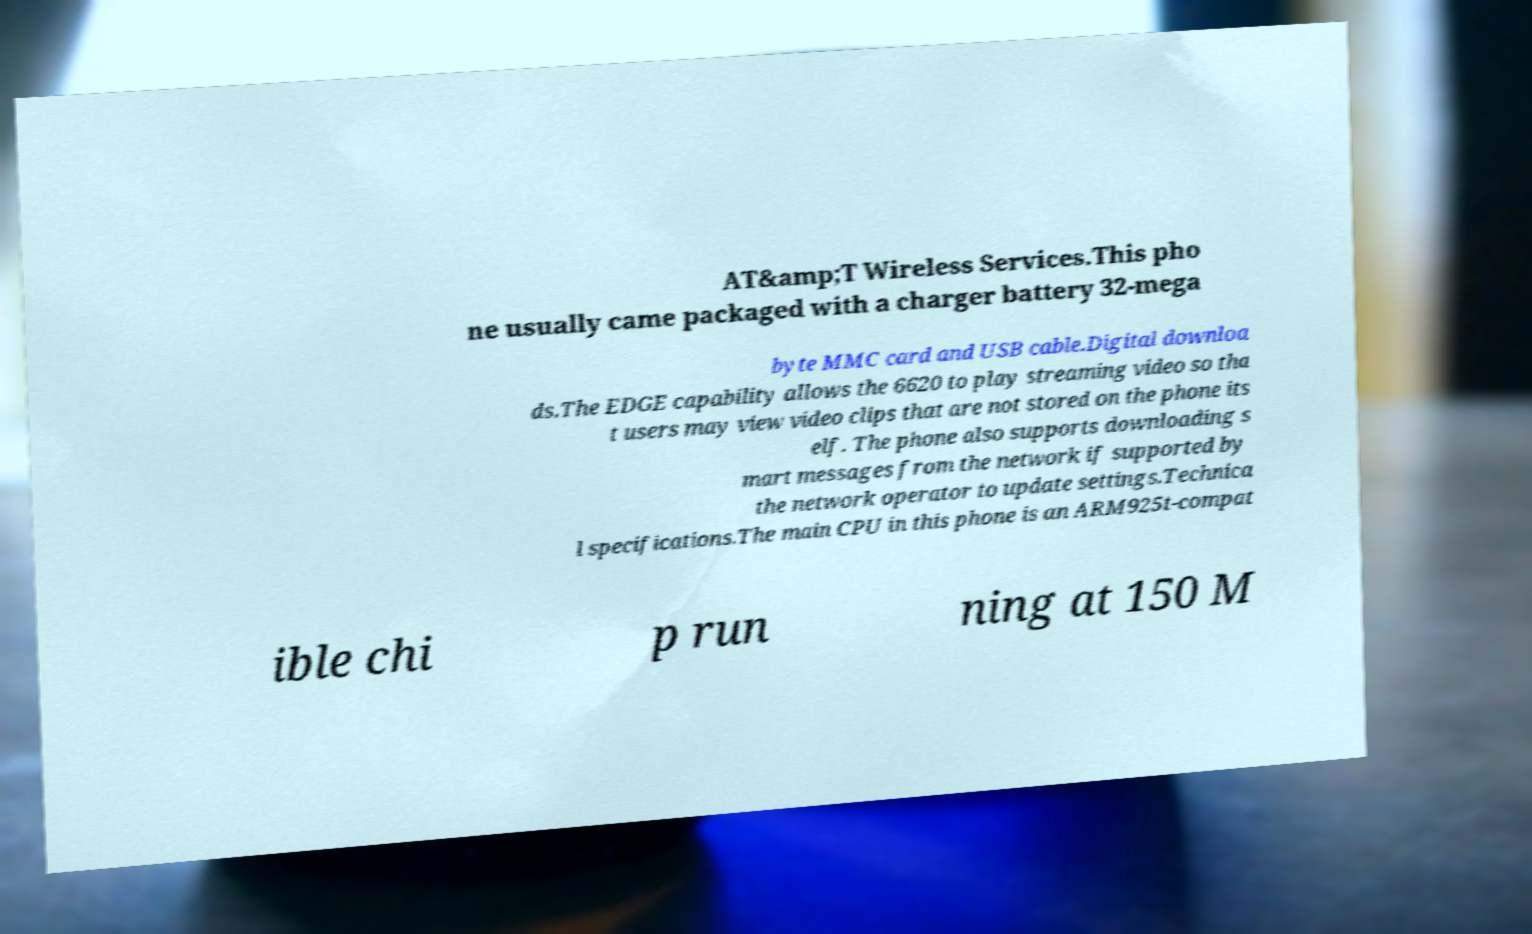For documentation purposes, I need the text within this image transcribed. Could you provide that? AT&amp;T Wireless Services.This pho ne usually came packaged with a charger battery 32-mega byte MMC card and USB cable.Digital downloa ds.The EDGE capability allows the 6620 to play streaming video so tha t users may view video clips that are not stored on the phone its elf. The phone also supports downloading s mart messages from the network if supported by the network operator to update settings.Technica l specifications.The main CPU in this phone is an ARM925t-compat ible chi p run ning at 150 M 